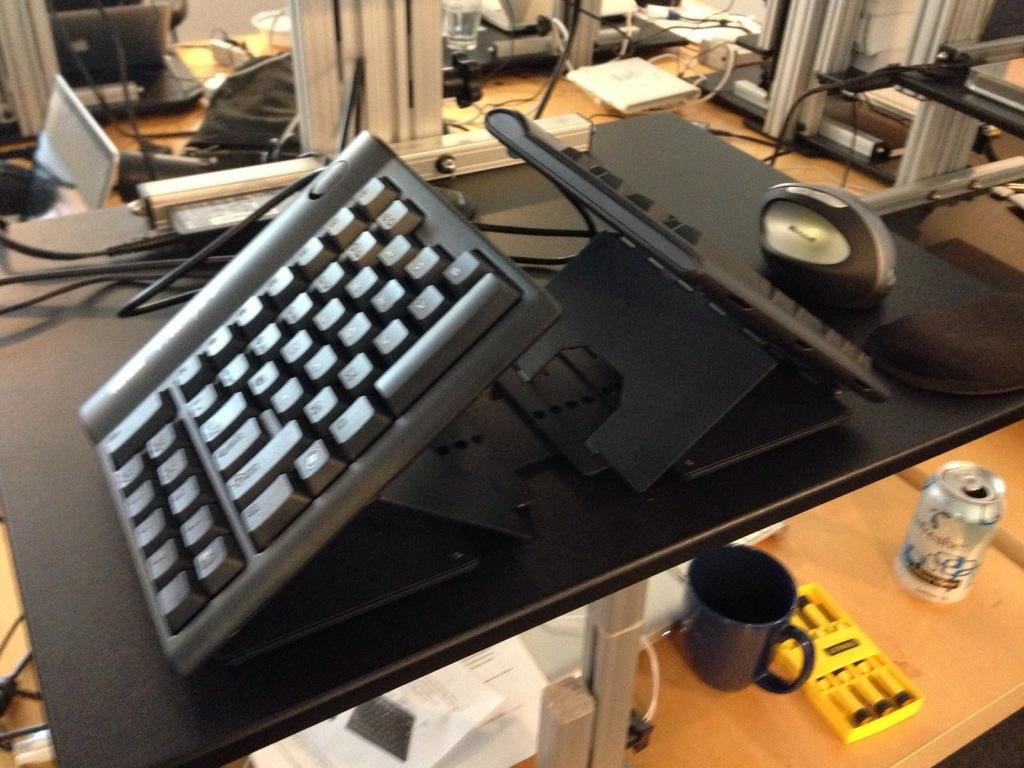What type of objects can be seen on the table in the image? There are keyboards, papers, a cup, and a tin on the table in the image. What is the purpose of the keyboards in the image? The keyboards are likely used for typing or inputting information. What is the tin used for in the image? The tin might be used for storing or containing small items. What can be seen in the background of the image? There are objects visible in the background of the image, but their specific details are not mentioned in the provided facts. How many eyes can be seen on the industry in the image? There is no industry present in the image, and therefore no eyes can be seen on it. 